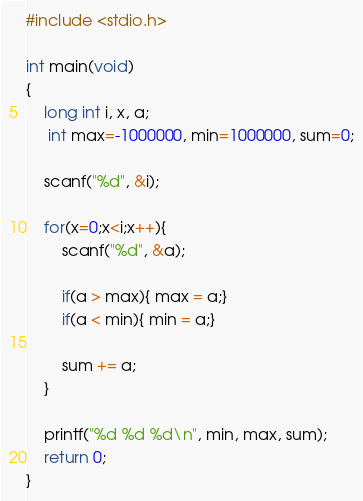Convert code to text. <code><loc_0><loc_0><loc_500><loc_500><_C_>#include <stdio.h>
 
int main(void)
{
    long int i, x, a;
     int max=-1000000, min=1000000, sum=0;
 
    scanf("%d", &i);
 
    for(x=0;x<i;x++){
        scanf("%d", &a);
     
        if(a > max){ max = a;}
        if(a < min){ min = a;}
         
        sum += a;
    }
 
    printf("%d %d %d\n", min, max, sum);
    return 0;
}  </code> 